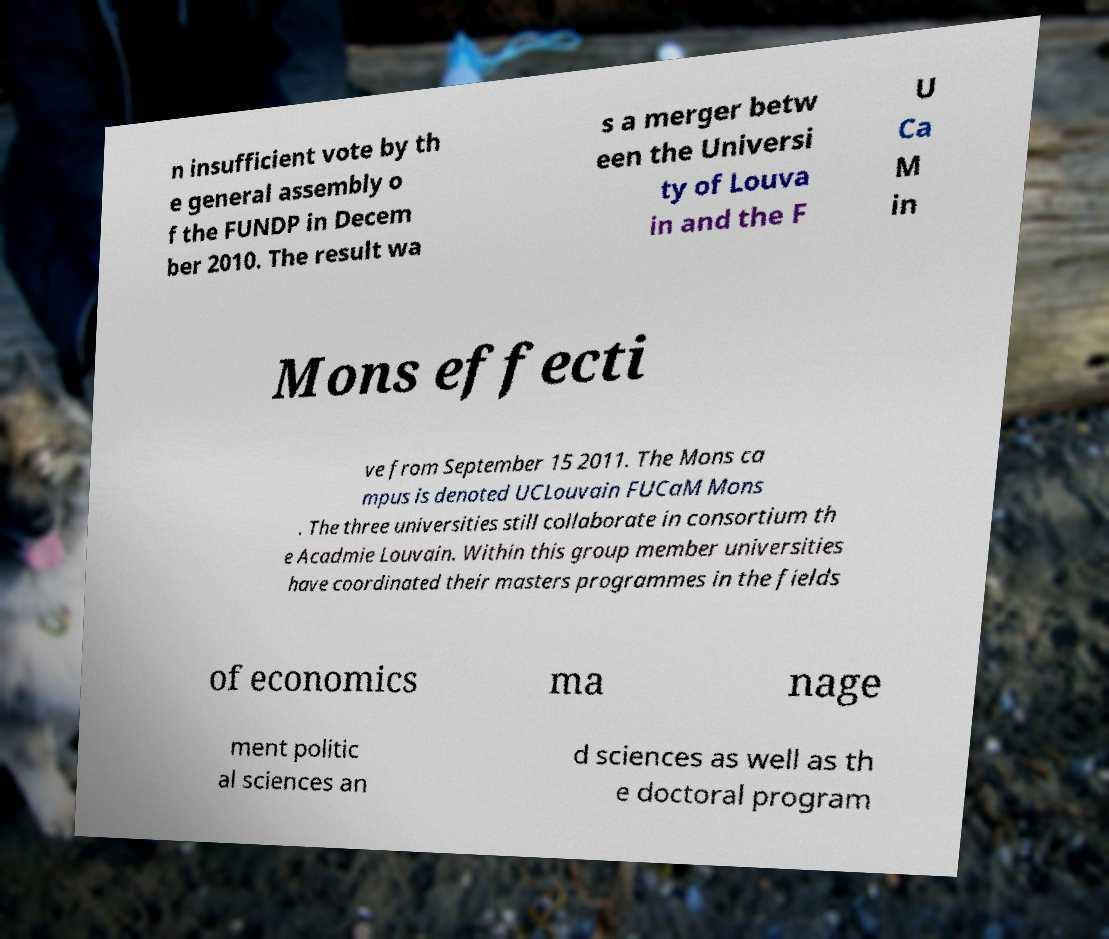For documentation purposes, I need the text within this image transcribed. Could you provide that? n insufficient vote by th e general assembly o f the FUNDP in Decem ber 2010. The result wa s a merger betw een the Universi ty of Louva in and the F U Ca M in Mons effecti ve from September 15 2011. The Mons ca mpus is denoted UCLouvain FUCaM Mons . The three universities still collaborate in consortium th e Acadmie Louvain. Within this group member universities have coordinated their masters programmes in the fields of economics ma nage ment politic al sciences an d sciences as well as th e doctoral program 